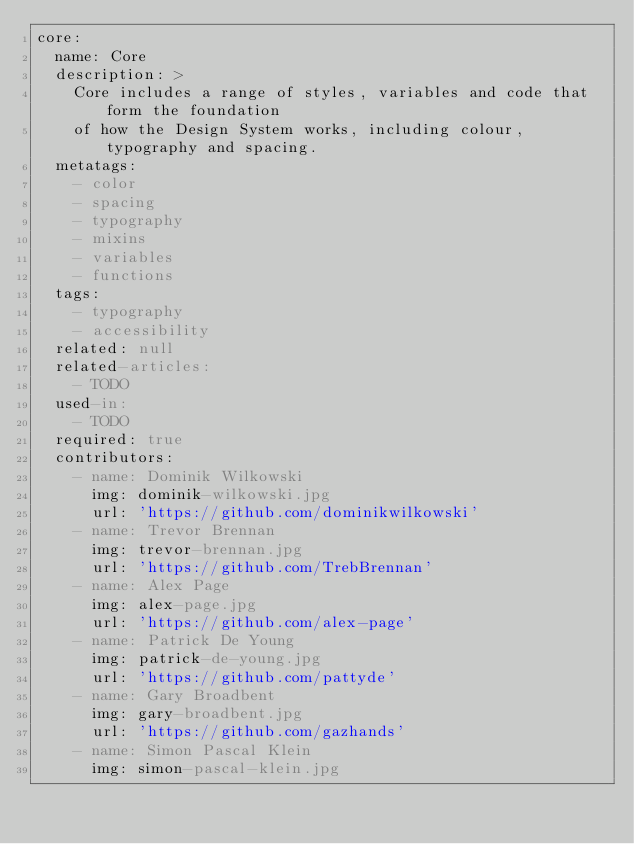Convert code to text. <code><loc_0><loc_0><loc_500><loc_500><_YAML_>core:
  name: Core
  description: >
    Core includes a range of styles, variables and code that form the foundation
    of how the Design System works, including colour, typography and spacing.
  metatags:
    - color
    - spacing
    - typography
    - mixins
    - variables
    - functions
  tags:
    - typography
    - accessibility
  related: null
  related-articles:
    - TODO
  used-in:
    - TODO
  required: true
  contributors:
    - name: Dominik Wilkowski
      img: dominik-wilkowski.jpg
      url: 'https://github.com/dominikwilkowski'
    - name: Trevor Brennan
      img: trevor-brennan.jpg
      url: 'https://github.com/TrebBrennan'
    - name: Alex Page
      img: alex-page.jpg
      url: 'https://github.com/alex-page'
    - name: Patrick De Young
      img: patrick-de-young.jpg
      url: 'https://github.com/pattyde'
    - name: Gary Broadbent
      img: gary-broadbent.jpg
      url: 'https://github.com/gazhands'
    - name: Simon Pascal Klein
      img: simon-pascal-klein.jpg</code> 